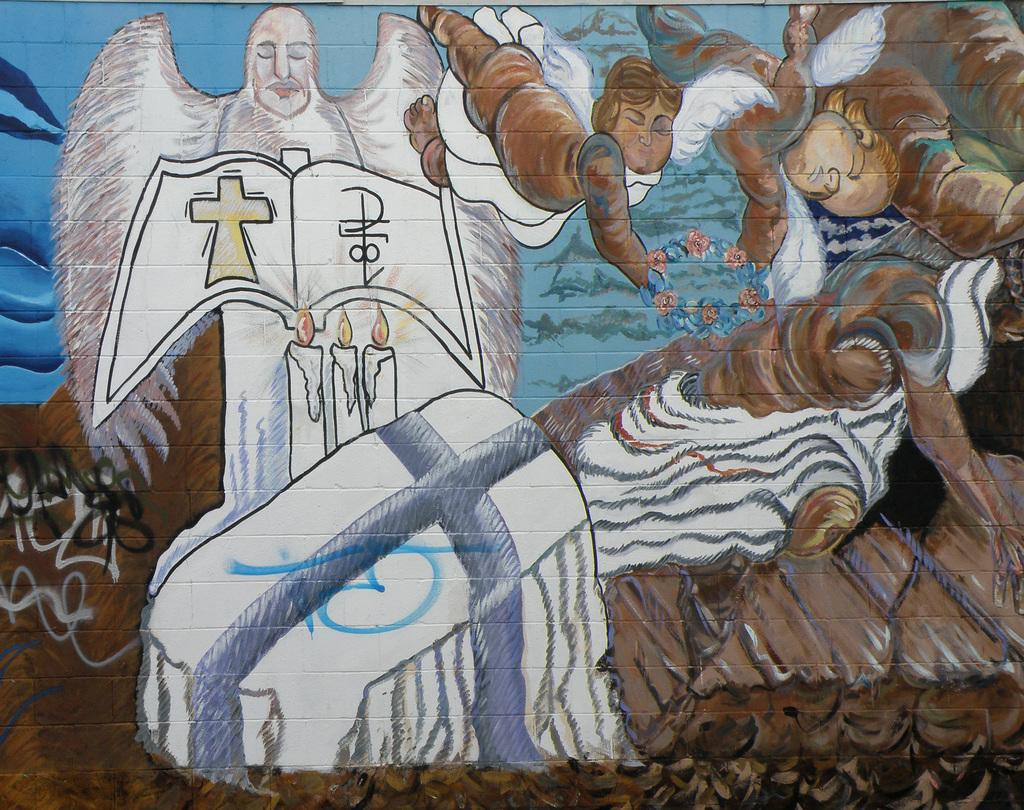What is depicted on the wall in the image? There is a painting on a wall in the image. How many spiders are crawling on the painting in the image? There are no spiders present in the image; it only features a painting on a wall. What is the tax rate for the home in the image? There is no information about a home or tax rate in the image; it only shows a painting on a wall. 